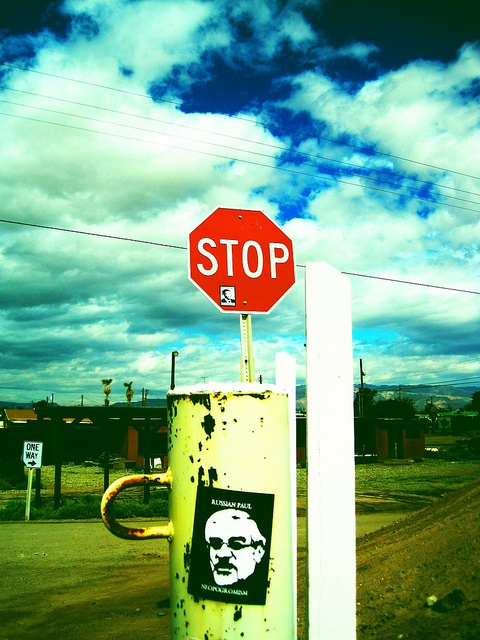Describe the objects in this image and their specific colors. I can see a stop sign in black, red, ivory, brown, and tan tones in this image. 